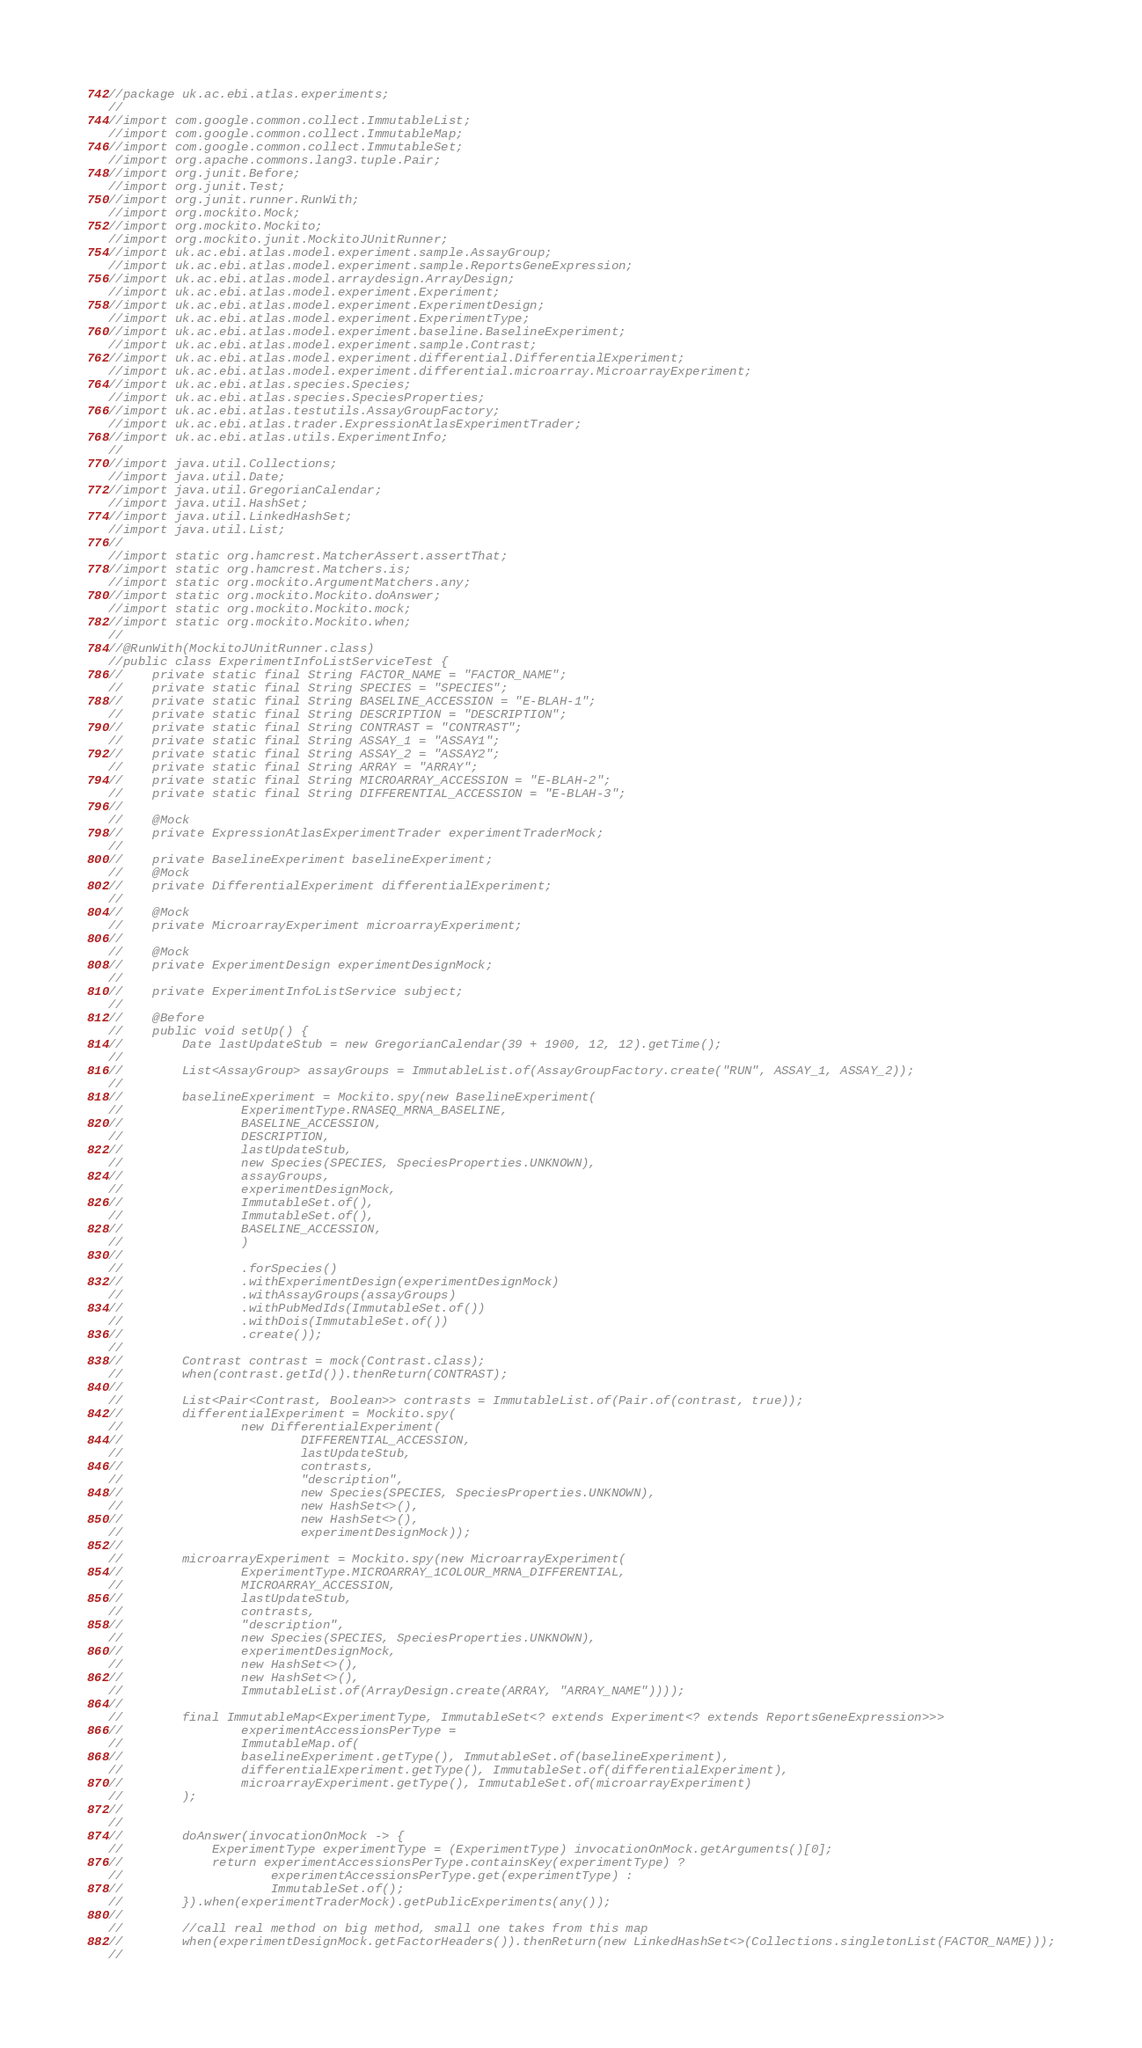Convert code to text. <code><loc_0><loc_0><loc_500><loc_500><_Java_>//package uk.ac.ebi.atlas.experiments;
//
//import com.google.common.collect.ImmutableList;
//import com.google.common.collect.ImmutableMap;
//import com.google.common.collect.ImmutableSet;
//import org.apache.commons.lang3.tuple.Pair;
//import org.junit.Before;
//import org.junit.Test;
//import org.junit.runner.RunWith;
//import org.mockito.Mock;
//import org.mockito.Mockito;
//import org.mockito.junit.MockitoJUnitRunner;
//import uk.ac.ebi.atlas.model.experiment.sample.AssayGroup;
//import uk.ac.ebi.atlas.model.experiment.sample.ReportsGeneExpression;
//import uk.ac.ebi.atlas.model.arraydesign.ArrayDesign;
//import uk.ac.ebi.atlas.model.experiment.Experiment;
//import uk.ac.ebi.atlas.model.experiment.ExperimentDesign;
//import uk.ac.ebi.atlas.model.experiment.ExperimentType;
//import uk.ac.ebi.atlas.model.experiment.baseline.BaselineExperiment;
//import uk.ac.ebi.atlas.model.experiment.sample.Contrast;
//import uk.ac.ebi.atlas.model.experiment.differential.DifferentialExperiment;
//import uk.ac.ebi.atlas.model.experiment.differential.microarray.MicroarrayExperiment;
//import uk.ac.ebi.atlas.species.Species;
//import uk.ac.ebi.atlas.species.SpeciesProperties;
//import uk.ac.ebi.atlas.testutils.AssayGroupFactory;
//import uk.ac.ebi.atlas.trader.ExpressionAtlasExperimentTrader;
//import uk.ac.ebi.atlas.utils.ExperimentInfo;
//
//import java.util.Collections;
//import java.util.Date;
//import java.util.GregorianCalendar;
//import java.util.HashSet;
//import java.util.LinkedHashSet;
//import java.util.List;
//
//import static org.hamcrest.MatcherAssert.assertThat;
//import static org.hamcrest.Matchers.is;
//import static org.mockito.ArgumentMatchers.any;
//import static org.mockito.Mockito.doAnswer;
//import static org.mockito.Mockito.mock;
//import static org.mockito.Mockito.when;
//
//@RunWith(MockitoJUnitRunner.class)
//public class ExperimentInfoListServiceTest {
//    private static final String FACTOR_NAME = "FACTOR_NAME";
//    private static final String SPECIES = "SPECIES";
//    private static final String BASELINE_ACCESSION = "E-BLAH-1";
//    private static final String DESCRIPTION = "DESCRIPTION";
//    private static final String CONTRAST = "CONTRAST";
//    private static final String ASSAY_1 = "ASSAY1";
//    private static final String ASSAY_2 = "ASSAY2";
//    private static final String ARRAY = "ARRAY";
//    private static final String MICROARRAY_ACCESSION = "E-BLAH-2";
//    private static final String DIFFERENTIAL_ACCESSION = "E-BLAH-3";
//
//    @Mock
//    private ExpressionAtlasExperimentTrader experimentTraderMock;
//
//    private BaselineExperiment baselineExperiment;
//    @Mock
//    private DifferentialExperiment differentialExperiment;
//
//    @Mock
//    private MicroarrayExperiment microarrayExperiment;
//
//    @Mock
//    private ExperimentDesign experimentDesignMock;
//
//    private ExperimentInfoListService subject;
//
//    @Before
//    public void setUp() {
//        Date lastUpdateStub = new GregorianCalendar(39 + 1900, 12, 12).getTime();
//
//        List<AssayGroup> assayGroups = ImmutableList.of(AssayGroupFactory.create("RUN", ASSAY_1, ASSAY_2));
//
//        baselineExperiment = Mockito.spy(new BaselineExperiment(
//                ExperimentType.RNASEQ_MRNA_BASELINE,
//                BASELINE_ACCESSION,
//                DESCRIPTION,
//                lastUpdateStub,
//                new Species(SPECIES, SpeciesProperties.UNKNOWN),
//                assayGroups,
//                experimentDesignMock,
//                ImmutableSet.of(),
//                ImmutableSet.of(),
//                BASELINE_ACCESSION,
//                )
//
//                .forSpecies()
//                .withExperimentDesign(experimentDesignMock)
//                .withAssayGroups(assayGroups)
//                .withPubMedIds(ImmutableSet.of())
//                .withDois(ImmutableSet.of())
//                .create());
//
//        Contrast contrast = mock(Contrast.class);
//        when(contrast.getId()).thenReturn(CONTRAST);
//
//        List<Pair<Contrast, Boolean>> contrasts = ImmutableList.of(Pair.of(contrast, true));
//        differentialExperiment = Mockito.spy(
//                new DifferentialExperiment(
//                        DIFFERENTIAL_ACCESSION,
//                        lastUpdateStub,
//                        contrasts,
//                        "description",
//                        new Species(SPECIES, SpeciesProperties.UNKNOWN),
//                        new HashSet<>(),
//                        new HashSet<>(),
//                        experimentDesignMock));
//
//        microarrayExperiment = Mockito.spy(new MicroarrayExperiment(
//                ExperimentType.MICROARRAY_1COLOUR_MRNA_DIFFERENTIAL,
//                MICROARRAY_ACCESSION,
//                lastUpdateStub,
//                contrasts,
//                "description",
//                new Species(SPECIES, SpeciesProperties.UNKNOWN),
//                experimentDesignMock,
//                new HashSet<>(),
//                new HashSet<>(),
//                ImmutableList.of(ArrayDesign.create(ARRAY, "ARRAY_NAME"))));
//
//        final ImmutableMap<ExperimentType, ImmutableSet<? extends Experiment<? extends ReportsGeneExpression>>>
//                experimentAccessionsPerType =
//                ImmutableMap.of(
//                baselineExperiment.getType(), ImmutableSet.of(baselineExperiment),
//                differentialExperiment.getType(), ImmutableSet.of(differentialExperiment),
//                microarrayExperiment.getType(), ImmutableSet.of(microarrayExperiment)
//        );
//
//
//        doAnswer(invocationOnMock -> {
//            ExperimentType experimentType = (ExperimentType) invocationOnMock.getArguments()[0];
//            return experimentAccessionsPerType.containsKey(experimentType) ?
//                    experimentAccessionsPerType.get(experimentType) :
//                    ImmutableSet.of();
//        }).when(experimentTraderMock).getPublicExperiments(any());
//
//        //call real method on big method, small one takes from this map
//        when(experimentDesignMock.getFactorHeaders()).thenReturn(new LinkedHashSet<>(Collections.singletonList(FACTOR_NAME)));
//</code> 